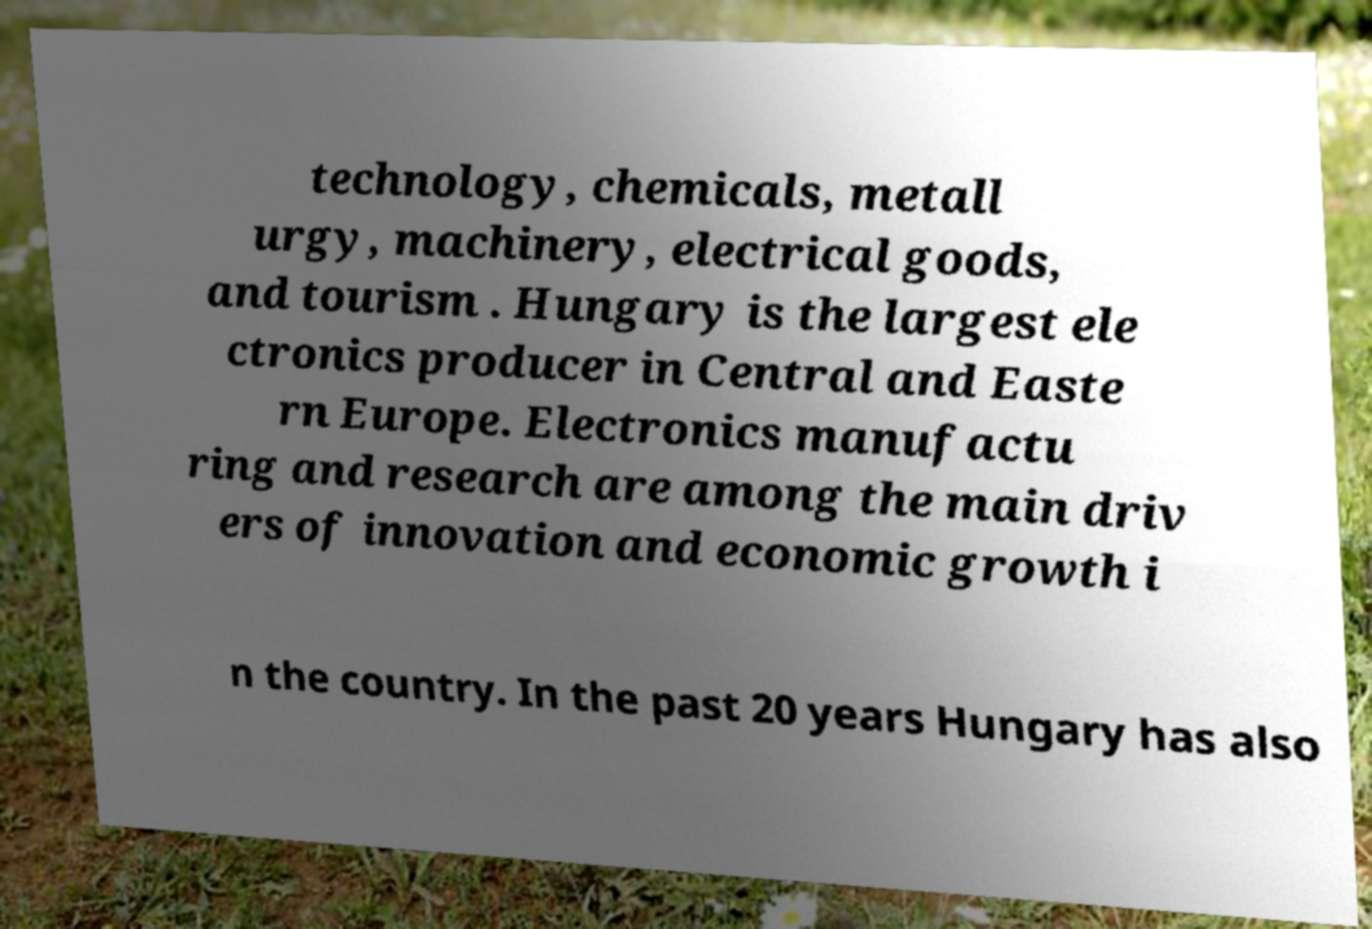Can you accurately transcribe the text from the provided image for me? technology, chemicals, metall urgy, machinery, electrical goods, and tourism . Hungary is the largest ele ctronics producer in Central and Easte rn Europe. Electronics manufactu ring and research are among the main driv ers of innovation and economic growth i n the country. In the past 20 years Hungary has also 